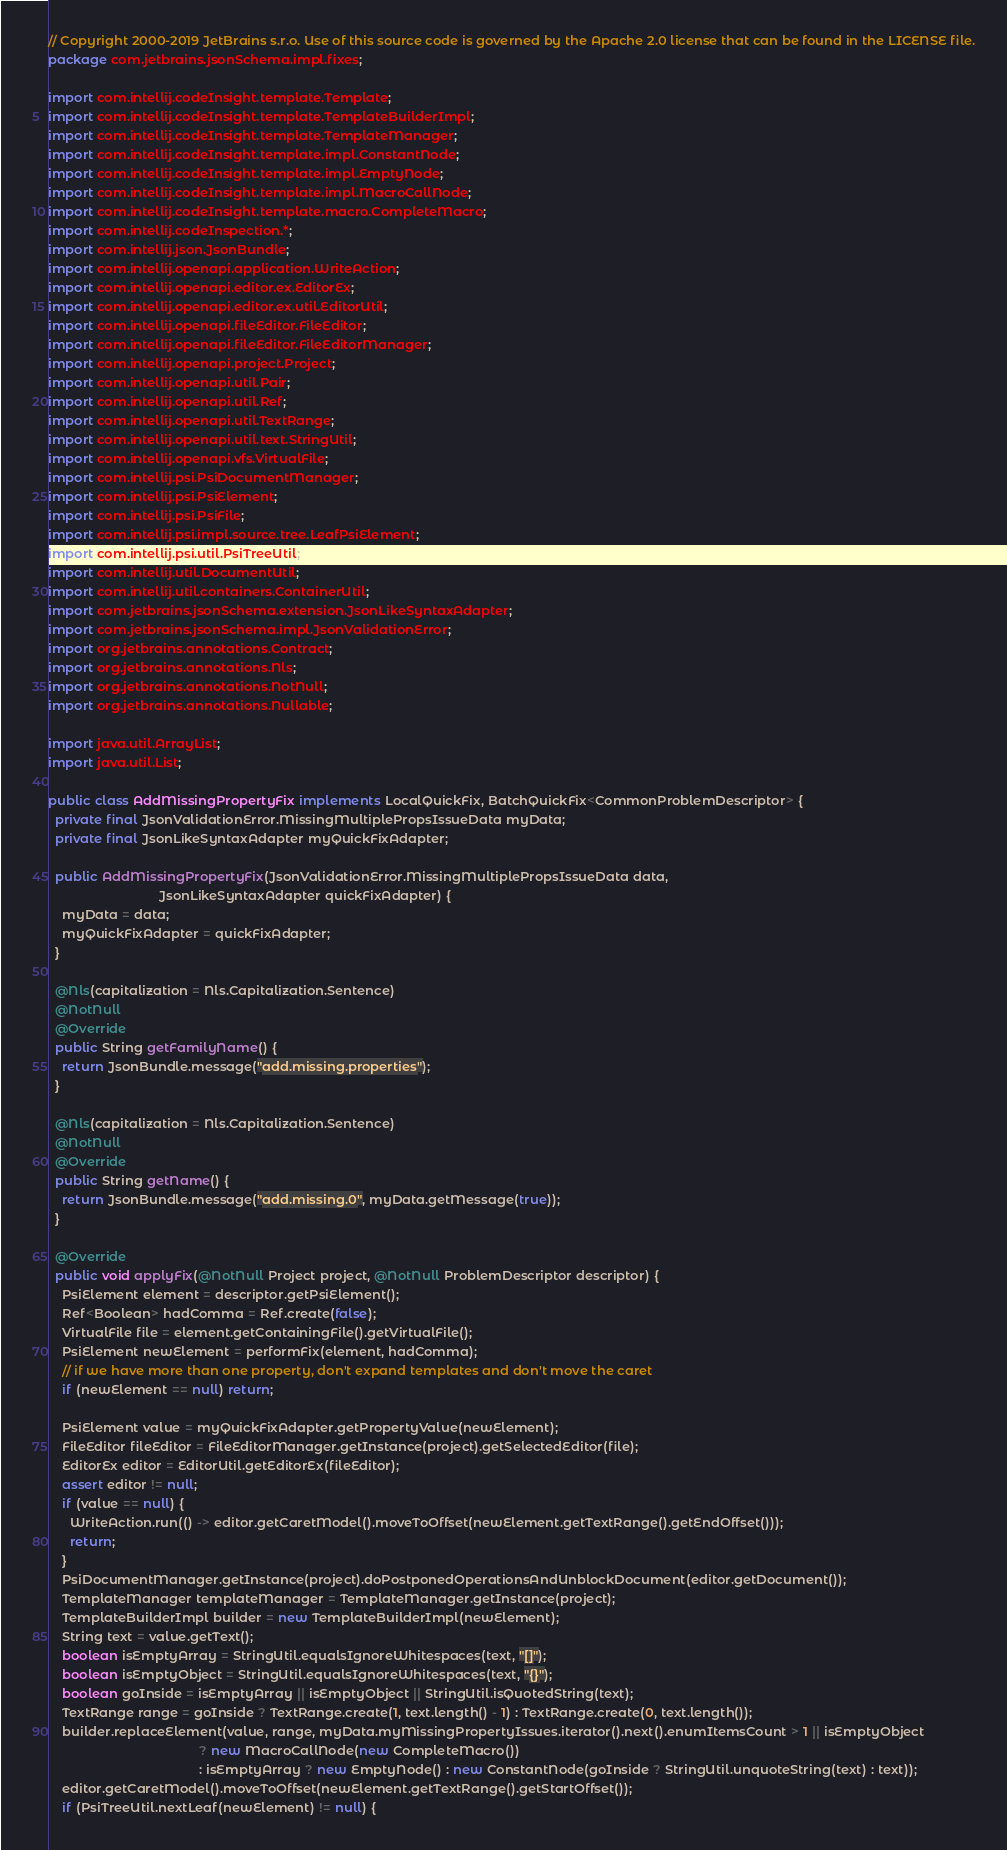Convert code to text. <code><loc_0><loc_0><loc_500><loc_500><_Java_>// Copyright 2000-2019 JetBrains s.r.o. Use of this source code is governed by the Apache 2.0 license that can be found in the LICENSE file.
package com.jetbrains.jsonSchema.impl.fixes;

import com.intellij.codeInsight.template.Template;
import com.intellij.codeInsight.template.TemplateBuilderImpl;
import com.intellij.codeInsight.template.TemplateManager;
import com.intellij.codeInsight.template.impl.ConstantNode;
import com.intellij.codeInsight.template.impl.EmptyNode;
import com.intellij.codeInsight.template.impl.MacroCallNode;
import com.intellij.codeInsight.template.macro.CompleteMacro;
import com.intellij.codeInspection.*;
import com.intellij.json.JsonBundle;
import com.intellij.openapi.application.WriteAction;
import com.intellij.openapi.editor.ex.EditorEx;
import com.intellij.openapi.editor.ex.util.EditorUtil;
import com.intellij.openapi.fileEditor.FileEditor;
import com.intellij.openapi.fileEditor.FileEditorManager;
import com.intellij.openapi.project.Project;
import com.intellij.openapi.util.Pair;
import com.intellij.openapi.util.Ref;
import com.intellij.openapi.util.TextRange;
import com.intellij.openapi.util.text.StringUtil;
import com.intellij.openapi.vfs.VirtualFile;
import com.intellij.psi.PsiDocumentManager;
import com.intellij.psi.PsiElement;
import com.intellij.psi.PsiFile;
import com.intellij.psi.impl.source.tree.LeafPsiElement;
import com.intellij.psi.util.PsiTreeUtil;
import com.intellij.util.DocumentUtil;
import com.intellij.util.containers.ContainerUtil;
import com.jetbrains.jsonSchema.extension.JsonLikeSyntaxAdapter;
import com.jetbrains.jsonSchema.impl.JsonValidationError;
import org.jetbrains.annotations.Contract;
import org.jetbrains.annotations.Nls;
import org.jetbrains.annotations.NotNull;
import org.jetbrains.annotations.Nullable;

import java.util.ArrayList;
import java.util.List;

public class AddMissingPropertyFix implements LocalQuickFix, BatchQuickFix<CommonProblemDescriptor> {
  private final JsonValidationError.MissingMultiplePropsIssueData myData;
  private final JsonLikeSyntaxAdapter myQuickFixAdapter;

  public AddMissingPropertyFix(JsonValidationError.MissingMultiplePropsIssueData data,
                               JsonLikeSyntaxAdapter quickFixAdapter) {
    myData = data;
    myQuickFixAdapter = quickFixAdapter;
  }

  @Nls(capitalization = Nls.Capitalization.Sentence)
  @NotNull
  @Override
  public String getFamilyName() {
    return JsonBundle.message("add.missing.properties");
  }

  @Nls(capitalization = Nls.Capitalization.Sentence)
  @NotNull
  @Override
  public String getName() {
    return JsonBundle.message("add.missing.0", myData.getMessage(true));
  }

  @Override
  public void applyFix(@NotNull Project project, @NotNull ProblemDescriptor descriptor) {
    PsiElement element = descriptor.getPsiElement();
    Ref<Boolean> hadComma = Ref.create(false);
    VirtualFile file = element.getContainingFile().getVirtualFile();
    PsiElement newElement = performFix(element, hadComma);
    // if we have more than one property, don't expand templates and don't move the caret
    if (newElement == null) return;

    PsiElement value = myQuickFixAdapter.getPropertyValue(newElement);
    FileEditor fileEditor = FileEditorManager.getInstance(project).getSelectedEditor(file);
    EditorEx editor = EditorUtil.getEditorEx(fileEditor);
    assert editor != null;
    if (value == null) {
      WriteAction.run(() -> editor.getCaretModel().moveToOffset(newElement.getTextRange().getEndOffset()));
      return;
    }
    PsiDocumentManager.getInstance(project).doPostponedOperationsAndUnblockDocument(editor.getDocument());
    TemplateManager templateManager = TemplateManager.getInstance(project);
    TemplateBuilderImpl builder = new TemplateBuilderImpl(newElement);
    String text = value.getText();
    boolean isEmptyArray = StringUtil.equalsIgnoreWhitespaces(text, "[]");
    boolean isEmptyObject = StringUtil.equalsIgnoreWhitespaces(text, "{}");
    boolean goInside = isEmptyArray || isEmptyObject || StringUtil.isQuotedString(text);
    TextRange range = goInside ? TextRange.create(1, text.length() - 1) : TextRange.create(0, text.length());
    builder.replaceElement(value, range, myData.myMissingPropertyIssues.iterator().next().enumItemsCount > 1 || isEmptyObject
                                          ? new MacroCallNode(new CompleteMacro())
                                          : isEmptyArray ? new EmptyNode() : new ConstantNode(goInside ? StringUtil.unquoteString(text) : text));
    editor.getCaretModel().moveToOffset(newElement.getTextRange().getStartOffset());
    if (PsiTreeUtil.nextLeaf(newElement) != null) {</code> 